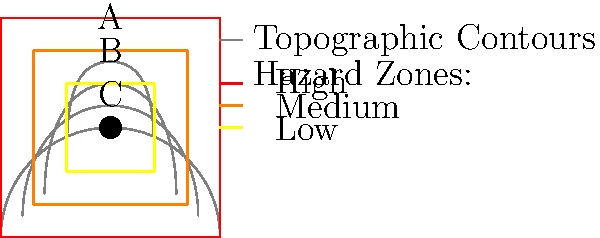Match the volcanic hazard zones (A, B, C) to the appropriate risk levels (High, Medium, Low) based on the topographic map contours surrounding an active volcano. What is the correct order of risk levels from outermost to innermost zone? To determine the correct order of risk levels from outermost to innermost zone, we need to analyze the topographic contours and hazard zones:

1. Observe that the contour lines are closely spaced near the center, indicating steeper slopes near the volcano's peak.

2. The hazard zones are represented by three concentric areas:
   - Zone A: Outermost (largest) zone
   - Zone B: Middle zone
   - Zone C: Innermost (smallest) zone

3. In volcanology, areas closer to the volcano's peak generally face higher risks due to:
   - Proximity to the eruption source
   - Steeper slopes leading to faster-moving lahars and pyroclastic flows
   - Higher likelihood of being affected by ballistic ejecta

4. Therefore, we can assign risk levels as follows:
   - Zone A (outermost): Low risk
   - Zone B (middle): Medium risk
   - Zone C (innermost): High risk

5. The correct order of risk levels from outermost to innermost zone is:
   Low (A) → Medium (B) → High (C)
Answer: Low, Medium, High 